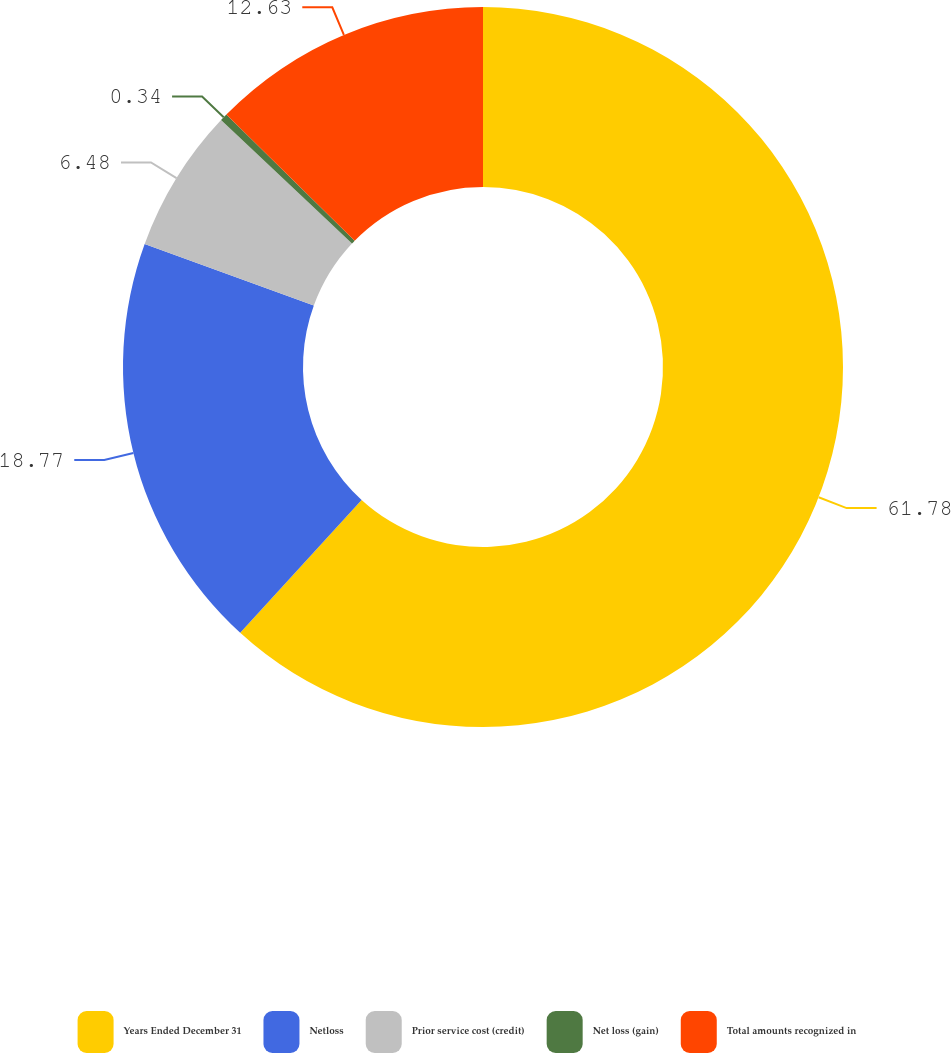Convert chart. <chart><loc_0><loc_0><loc_500><loc_500><pie_chart><fcel>Years Ended December 31<fcel>Netloss<fcel>Prior service cost (credit)<fcel>Net loss (gain)<fcel>Total amounts recognized in<nl><fcel>61.78%<fcel>18.77%<fcel>6.48%<fcel>0.34%<fcel>12.63%<nl></chart> 